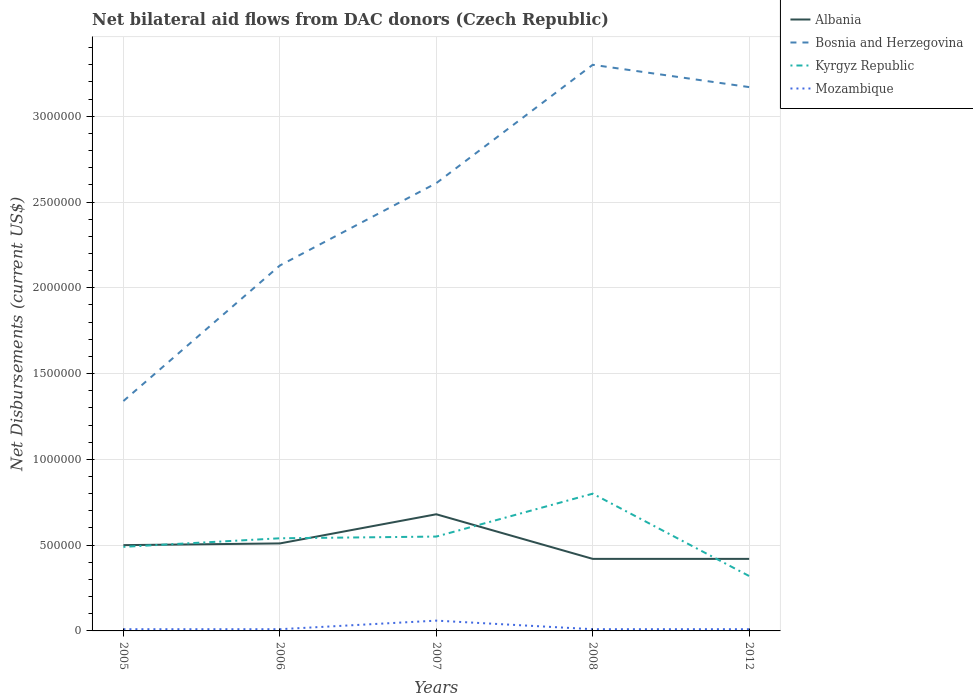Does the line corresponding to Bosnia and Herzegovina intersect with the line corresponding to Albania?
Your answer should be compact. No. In which year was the net bilateral aid flows in Kyrgyz Republic maximum?
Offer a terse response. 2012. What is the total net bilateral aid flows in Albania in the graph?
Your answer should be very brief. 9.00e+04. What is the difference between the highest and the lowest net bilateral aid flows in Bosnia and Herzegovina?
Ensure brevity in your answer.  3. How many lines are there?
Keep it short and to the point. 4. What is the difference between two consecutive major ticks on the Y-axis?
Your response must be concise. 5.00e+05. Are the values on the major ticks of Y-axis written in scientific E-notation?
Give a very brief answer. No. How many legend labels are there?
Provide a short and direct response. 4. What is the title of the graph?
Make the answer very short. Net bilateral aid flows from DAC donors (Czech Republic). What is the label or title of the Y-axis?
Ensure brevity in your answer.  Net Disbursements (current US$). What is the Net Disbursements (current US$) in Bosnia and Herzegovina in 2005?
Offer a terse response. 1.34e+06. What is the Net Disbursements (current US$) in Kyrgyz Republic in 2005?
Make the answer very short. 4.90e+05. What is the Net Disbursements (current US$) in Mozambique in 2005?
Your answer should be very brief. 10000. What is the Net Disbursements (current US$) of Albania in 2006?
Offer a very short reply. 5.10e+05. What is the Net Disbursements (current US$) of Bosnia and Herzegovina in 2006?
Your response must be concise. 2.13e+06. What is the Net Disbursements (current US$) of Kyrgyz Republic in 2006?
Provide a succinct answer. 5.40e+05. What is the Net Disbursements (current US$) in Mozambique in 2006?
Provide a short and direct response. 10000. What is the Net Disbursements (current US$) of Albania in 2007?
Your answer should be compact. 6.80e+05. What is the Net Disbursements (current US$) of Bosnia and Herzegovina in 2007?
Give a very brief answer. 2.61e+06. What is the Net Disbursements (current US$) of Kyrgyz Republic in 2007?
Your answer should be compact. 5.50e+05. What is the Net Disbursements (current US$) in Bosnia and Herzegovina in 2008?
Keep it short and to the point. 3.30e+06. What is the Net Disbursements (current US$) in Kyrgyz Republic in 2008?
Provide a short and direct response. 8.00e+05. What is the Net Disbursements (current US$) in Mozambique in 2008?
Provide a succinct answer. 10000. What is the Net Disbursements (current US$) of Bosnia and Herzegovina in 2012?
Your response must be concise. 3.17e+06. What is the Net Disbursements (current US$) in Kyrgyz Republic in 2012?
Offer a very short reply. 3.20e+05. What is the Net Disbursements (current US$) in Mozambique in 2012?
Provide a short and direct response. 10000. Across all years, what is the maximum Net Disbursements (current US$) in Albania?
Offer a terse response. 6.80e+05. Across all years, what is the maximum Net Disbursements (current US$) in Bosnia and Herzegovina?
Provide a succinct answer. 3.30e+06. Across all years, what is the maximum Net Disbursements (current US$) of Kyrgyz Republic?
Your answer should be compact. 8.00e+05. Across all years, what is the maximum Net Disbursements (current US$) in Mozambique?
Make the answer very short. 6.00e+04. Across all years, what is the minimum Net Disbursements (current US$) in Bosnia and Herzegovina?
Ensure brevity in your answer.  1.34e+06. Across all years, what is the minimum Net Disbursements (current US$) of Mozambique?
Keep it short and to the point. 10000. What is the total Net Disbursements (current US$) in Albania in the graph?
Provide a short and direct response. 2.53e+06. What is the total Net Disbursements (current US$) of Bosnia and Herzegovina in the graph?
Keep it short and to the point. 1.26e+07. What is the total Net Disbursements (current US$) of Kyrgyz Republic in the graph?
Your answer should be compact. 2.70e+06. What is the difference between the Net Disbursements (current US$) in Albania in 2005 and that in 2006?
Your response must be concise. -10000. What is the difference between the Net Disbursements (current US$) of Bosnia and Herzegovina in 2005 and that in 2006?
Provide a short and direct response. -7.90e+05. What is the difference between the Net Disbursements (current US$) of Mozambique in 2005 and that in 2006?
Keep it short and to the point. 0. What is the difference between the Net Disbursements (current US$) in Bosnia and Herzegovina in 2005 and that in 2007?
Your answer should be very brief. -1.27e+06. What is the difference between the Net Disbursements (current US$) in Kyrgyz Republic in 2005 and that in 2007?
Ensure brevity in your answer.  -6.00e+04. What is the difference between the Net Disbursements (current US$) of Bosnia and Herzegovina in 2005 and that in 2008?
Your answer should be compact. -1.96e+06. What is the difference between the Net Disbursements (current US$) in Kyrgyz Republic in 2005 and that in 2008?
Provide a short and direct response. -3.10e+05. What is the difference between the Net Disbursements (current US$) in Albania in 2005 and that in 2012?
Offer a terse response. 8.00e+04. What is the difference between the Net Disbursements (current US$) in Bosnia and Herzegovina in 2005 and that in 2012?
Provide a succinct answer. -1.83e+06. What is the difference between the Net Disbursements (current US$) of Kyrgyz Republic in 2005 and that in 2012?
Offer a very short reply. 1.70e+05. What is the difference between the Net Disbursements (current US$) in Albania in 2006 and that in 2007?
Your answer should be compact. -1.70e+05. What is the difference between the Net Disbursements (current US$) of Bosnia and Herzegovina in 2006 and that in 2007?
Your answer should be compact. -4.80e+05. What is the difference between the Net Disbursements (current US$) in Kyrgyz Republic in 2006 and that in 2007?
Your answer should be compact. -10000. What is the difference between the Net Disbursements (current US$) of Albania in 2006 and that in 2008?
Ensure brevity in your answer.  9.00e+04. What is the difference between the Net Disbursements (current US$) of Bosnia and Herzegovina in 2006 and that in 2008?
Ensure brevity in your answer.  -1.17e+06. What is the difference between the Net Disbursements (current US$) of Kyrgyz Republic in 2006 and that in 2008?
Make the answer very short. -2.60e+05. What is the difference between the Net Disbursements (current US$) in Bosnia and Herzegovina in 2006 and that in 2012?
Ensure brevity in your answer.  -1.04e+06. What is the difference between the Net Disbursements (current US$) in Mozambique in 2006 and that in 2012?
Keep it short and to the point. 0. What is the difference between the Net Disbursements (current US$) of Bosnia and Herzegovina in 2007 and that in 2008?
Provide a short and direct response. -6.90e+05. What is the difference between the Net Disbursements (current US$) in Mozambique in 2007 and that in 2008?
Your response must be concise. 5.00e+04. What is the difference between the Net Disbursements (current US$) in Bosnia and Herzegovina in 2007 and that in 2012?
Your response must be concise. -5.60e+05. What is the difference between the Net Disbursements (current US$) of Kyrgyz Republic in 2007 and that in 2012?
Give a very brief answer. 2.30e+05. What is the difference between the Net Disbursements (current US$) of Mozambique in 2007 and that in 2012?
Give a very brief answer. 5.00e+04. What is the difference between the Net Disbursements (current US$) of Bosnia and Herzegovina in 2008 and that in 2012?
Ensure brevity in your answer.  1.30e+05. What is the difference between the Net Disbursements (current US$) in Mozambique in 2008 and that in 2012?
Your answer should be very brief. 0. What is the difference between the Net Disbursements (current US$) in Albania in 2005 and the Net Disbursements (current US$) in Bosnia and Herzegovina in 2006?
Make the answer very short. -1.63e+06. What is the difference between the Net Disbursements (current US$) of Albania in 2005 and the Net Disbursements (current US$) of Mozambique in 2006?
Offer a terse response. 4.90e+05. What is the difference between the Net Disbursements (current US$) in Bosnia and Herzegovina in 2005 and the Net Disbursements (current US$) in Kyrgyz Republic in 2006?
Provide a succinct answer. 8.00e+05. What is the difference between the Net Disbursements (current US$) in Bosnia and Herzegovina in 2005 and the Net Disbursements (current US$) in Mozambique in 2006?
Give a very brief answer. 1.33e+06. What is the difference between the Net Disbursements (current US$) of Kyrgyz Republic in 2005 and the Net Disbursements (current US$) of Mozambique in 2006?
Your answer should be very brief. 4.80e+05. What is the difference between the Net Disbursements (current US$) of Albania in 2005 and the Net Disbursements (current US$) of Bosnia and Herzegovina in 2007?
Provide a succinct answer. -2.11e+06. What is the difference between the Net Disbursements (current US$) in Bosnia and Herzegovina in 2005 and the Net Disbursements (current US$) in Kyrgyz Republic in 2007?
Your response must be concise. 7.90e+05. What is the difference between the Net Disbursements (current US$) in Bosnia and Herzegovina in 2005 and the Net Disbursements (current US$) in Mozambique in 2007?
Offer a terse response. 1.28e+06. What is the difference between the Net Disbursements (current US$) in Kyrgyz Republic in 2005 and the Net Disbursements (current US$) in Mozambique in 2007?
Your answer should be very brief. 4.30e+05. What is the difference between the Net Disbursements (current US$) of Albania in 2005 and the Net Disbursements (current US$) of Bosnia and Herzegovina in 2008?
Offer a very short reply. -2.80e+06. What is the difference between the Net Disbursements (current US$) in Bosnia and Herzegovina in 2005 and the Net Disbursements (current US$) in Kyrgyz Republic in 2008?
Make the answer very short. 5.40e+05. What is the difference between the Net Disbursements (current US$) in Bosnia and Herzegovina in 2005 and the Net Disbursements (current US$) in Mozambique in 2008?
Make the answer very short. 1.33e+06. What is the difference between the Net Disbursements (current US$) of Kyrgyz Republic in 2005 and the Net Disbursements (current US$) of Mozambique in 2008?
Your answer should be compact. 4.80e+05. What is the difference between the Net Disbursements (current US$) of Albania in 2005 and the Net Disbursements (current US$) of Bosnia and Herzegovina in 2012?
Your answer should be compact. -2.67e+06. What is the difference between the Net Disbursements (current US$) in Albania in 2005 and the Net Disbursements (current US$) in Kyrgyz Republic in 2012?
Keep it short and to the point. 1.80e+05. What is the difference between the Net Disbursements (current US$) in Albania in 2005 and the Net Disbursements (current US$) in Mozambique in 2012?
Your answer should be very brief. 4.90e+05. What is the difference between the Net Disbursements (current US$) in Bosnia and Herzegovina in 2005 and the Net Disbursements (current US$) in Kyrgyz Republic in 2012?
Provide a short and direct response. 1.02e+06. What is the difference between the Net Disbursements (current US$) of Bosnia and Herzegovina in 2005 and the Net Disbursements (current US$) of Mozambique in 2012?
Provide a short and direct response. 1.33e+06. What is the difference between the Net Disbursements (current US$) of Albania in 2006 and the Net Disbursements (current US$) of Bosnia and Herzegovina in 2007?
Your answer should be very brief. -2.10e+06. What is the difference between the Net Disbursements (current US$) in Bosnia and Herzegovina in 2006 and the Net Disbursements (current US$) in Kyrgyz Republic in 2007?
Provide a short and direct response. 1.58e+06. What is the difference between the Net Disbursements (current US$) in Bosnia and Herzegovina in 2006 and the Net Disbursements (current US$) in Mozambique in 2007?
Make the answer very short. 2.07e+06. What is the difference between the Net Disbursements (current US$) in Albania in 2006 and the Net Disbursements (current US$) in Bosnia and Herzegovina in 2008?
Offer a very short reply. -2.79e+06. What is the difference between the Net Disbursements (current US$) in Albania in 2006 and the Net Disbursements (current US$) in Mozambique in 2008?
Offer a terse response. 5.00e+05. What is the difference between the Net Disbursements (current US$) of Bosnia and Herzegovina in 2006 and the Net Disbursements (current US$) of Kyrgyz Republic in 2008?
Make the answer very short. 1.33e+06. What is the difference between the Net Disbursements (current US$) in Bosnia and Herzegovina in 2006 and the Net Disbursements (current US$) in Mozambique in 2008?
Your response must be concise. 2.12e+06. What is the difference between the Net Disbursements (current US$) of Kyrgyz Republic in 2006 and the Net Disbursements (current US$) of Mozambique in 2008?
Make the answer very short. 5.30e+05. What is the difference between the Net Disbursements (current US$) of Albania in 2006 and the Net Disbursements (current US$) of Bosnia and Herzegovina in 2012?
Make the answer very short. -2.66e+06. What is the difference between the Net Disbursements (current US$) in Albania in 2006 and the Net Disbursements (current US$) in Kyrgyz Republic in 2012?
Keep it short and to the point. 1.90e+05. What is the difference between the Net Disbursements (current US$) in Bosnia and Herzegovina in 2006 and the Net Disbursements (current US$) in Kyrgyz Republic in 2012?
Offer a very short reply. 1.81e+06. What is the difference between the Net Disbursements (current US$) in Bosnia and Herzegovina in 2006 and the Net Disbursements (current US$) in Mozambique in 2012?
Provide a short and direct response. 2.12e+06. What is the difference between the Net Disbursements (current US$) of Kyrgyz Republic in 2006 and the Net Disbursements (current US$) of Mozambique in 2012?
Offer a very short reply. 5.30e+05. What is the difference between the Net Disbursements (current US$) of Albania in 2007 and the Net Disbursements (current US$) of Bosnia and Herzegovina in 2008?
Keep it short and to the point. -2.62e+06. What is the difference between the Net Disbursements (current US$) in Albania in 2007 and the Net Disbursements (current US$) in Kyrgyz Republic in 2008?
Your response must be concise. -1.20e+05. What is the difference between the Net Disbursements (current US$) of Albania in 2007 and the Net Disbursements (current US$) of Mozambique in 2008?
Your answer should be very brief. 6.70e+05. What is the difference between the Net Disbursements (current US$) in Bosnia and Herzegovina in 2007 and the Net Disbursements (current US$) in Kyrgyz Republic in 2008?
Provide a short and direct response. 1.81e+06. What is the difference between the Net Disbursements (current US$) in Bosnia and Herzegovina in 2007 and the Net Disbursements (current US$) in Mozambique in 2008?
Give a very brief answer. 2.60e+06. What is the difference between the Net Disbursements (current US$) of Kyrgyz Republic in 2007 and the Net Disbursements (current US$) of Mozambique in 2008?
Give a very brief answer. 5.40e+05. What is the difference between the Net Disbursements (current US$) of Albania in 2007 and the Net Disbursements (current US$) of Bosnia and Herzegovina in 2012?
Make the answer very short. -2.49e+06. What is the difference between the Net Disbursements (current US$) in Albania in 2007 and the Net Disbursements (current US$) in Kyrgyz Republic in 2012?
Keep it short and to the point. 3.60e+05. What is the difference between the Net Disbursements (current US$) in Albania in 2007 and the Net Disbursements (current US$) in Mozambique in 2012?
Offer a terse response. 6.70e+05. What is the difference between the Net Disbursements (current US$) of Bosnia and Herzegovina in 2007 and the Net Disbursements (current US$) of Kyrgyz Republic in 2012?
Provide a short and direct response. 2.29e+06. What is the difference between the Net Disbursements (current US$) of Bosnia and Herzegovina in 2007 and the Net Disbursements (current US$) of Mozambique in 2012?
Keep it short and to the point. 2.60e+06. What is the difference between the Net Disbursements (current US$) of Kyrgyz Republic in 2007 and the Net Disbursements (current US$) of Mozambique in 2012?
Provide a succinct answer. 5.40e+05. What is the difference between the Net Disbursements (current US$) of Albania in 2008 and the Net Disbursements (current US$) of Bosnia and Herzegovina in 2012?
Your answer should be compact. -2.75e+06. What is the difference between the Net Disbursements (current US$) of Albania in 2008 and the Net Disbursements (current US$) of Kyrgyz Republic in 2012?
Offer a terse response. 1.00e+05. What is the difference between the Net Disbursements (current US$) in Albania in 2008 and the Net Disbursements (current US$) in Mozambique in 2012?
Provide a succinct answer. 4.10e+05. What is the difference between the Net Disbursements (current US$) of Bosnia and Herzegovina in 2008 and the Net Disbursements (current US$) of Kyrgyz Republic in 2012?
Ensure brevity in your answer.  2.98e+06. What is the difference between the Net Disbursements (current US$) of Bosnia and Herzegovina in 2008 and the Net Disbursements (current US$) of Mozambique in 2012?
Your answer should be very brief. 3.29e+06. What is the difference between the Net Disbursements (current US$) in Kyrgyz Republic in 2008 and the Net Disbursements (current US$) in Mozambique in 2012?
Ensure brevity in your answer.  7.90e+05. What is the average Net Disbursements (current US$) of Albania per year?
Give a very brief answer. 5.06e+05. What is the average Net Disbursements (current US$) in Bosnia and Herzegovina per year?
Offer a terse response. 2.51e+06. What is the average Net Disbursements (current US$) of Kyrgyz Republic per year?
Your answer should be very brief. 5.40e+05. In the year 2005, what is the difference between the Net Disbursements (current US$) in Albania and Net Disbursements (current US$) in Bosnia and Herzegovina?
Your answer should be very brief. -8.40e+05. In the year 2005, what is the difference between the Net Disbursements (current US$) in Albania and Net Disbursements (current US$) in Mozambique?
Give a very brief answer. 4.90e+05. In the year 2005, what is the difference between the Net Disbursements (current US$) of Bosnia and Herzegovina and Net Disbursements (current US$) of Kyrgyz Republic?
Keep it short and to the point. 8.50e+05. In the year 2005, what is the difference between the Net Disbursements (current US$) in Bosnia and Herzegovina and Net Disbursements (current US$) in Mozambique?
Give a very brief answer. 1.33e+06. In the year 2006, what is the difference between the Net Disbursements (current US$) of Albania and Net Disbursements (current US$) of Bosnia and Herzegovina?
Ensure brevity in your answer.  -1.62e+06. In the year 2006, what is the difference between the Net Disbursements (current US$) of Albania and Net Disbursements (current US$) of Kyrgyz Republic?
Offer a terse response. -3.00e+04. In the year 2006, what is the difference between the Net Disbursements (current US$) of Bosnia and Herzegovina and Net Disbursements (current US$) of Kyrgyz Republic?
Your answer should be very brief. 1.59e+06. In the year 2006, what is the difference between the Net Disbursements (current US$) of Bosnia and Herzegovina and Net Disbursements (current US$) of Mozambique?
Offer a very short reply. 2.12e+06. In the year 2006, what is the difference between the Net Disbursements (current US$) of Kyrgyz Republic and Net Disbursements (current US$) of Mozambique?
Provide a short and direct response. 5.30e+05. In the year 2007, what is the difference between the Net Disbursements (current US$) in Albania and Net Disbursements (current US$) in Bosnia and Herzegovina?
Provide a succinct answer. -1.93e+06. In the year 2007, what is the difference between the Net Disbursements (current US$) in Albania and Net Disbursements (current US$) in Mozambique?
Offer a very short reply. 6.20e+05. In the year 2007, what is the difference between the Net Disbursements (current US$) in Bosnia and Herzegovina and Net Disbursements (current US$) in Kyrgyz Republic?
Keep it short and to the point. 2.06e+06. In the year 2007, what is the difference between the Net Disbursements (current US$) in Bosnia and Herzegovina and Net Disbursements (current US$) in Mozambique?
Offer a very short reply. 2.55e+06. In the year 2007, what is the difference between the Net Disbursements (current US$) of Kyrgyz Republic and Net Disbursements (current US$) of Mozambique?
Provide a succinct answer. 4.90e+05. In the year 2008, what is the difference between the Net Disbursements (current US$) of Albania and Net Disbursements (current US$) of Bosnia and Herzegovina?
Give a very brief answer. -2.88e+06. In the year 2008, what is the difference between the Net Disbursements (current US$) in Albania and Net Disbursements (current US$) in Kyrgyz Republic?
Your response must be concise. -3.80e+05. In the year 2008, what is the difference between the Net Disbursements (current US$) of Albania and Net Disbursements (current US$) of Mozambique?
Your response must be concise. 4.10e+05. In the year 2008, what is the difference between the Net Disbursements (current US$) in Bosnia and Herzegovina and Net Disbursements (current US$) in Kyrgyz Republic?
Ensure brevity in your answer.  2.50e+06. In the year 2008, what is the difference between the Net Disbursements (current US$) of Bosnia and Herzegovina and Net Disbursements (current US$) of Mozambique?
Your response must be concise. 3.29e+06. In the year 2008, what is the difference between the Net Disbursements (current US$) in Kyrgyz Republic and Net Disbursements (current US$) in Mozambique?
Provide a short and direct response. 7.90e+05. In the year 2012, what is the difference between the Net Disbursements (current US$) of Albania and Net Disbursements (current US$) of Bosnia and Herzegovina?
Make the answer very short. -2.75e+06. In the year 2012, what is the difference between the Net Disbursements (current US$) of Bosnia and Herzegovina and Net Disbursements (current US$) of Kyrgyz Republic?
Your answer should be compact. 2.85e+06. In the year 2012, what is the difference between the Net Disbursements (current US$) in Bosnia and Herzegovina and Net Disbursements (current US$) in Mozambique?
Give a very brief answer. 3.16e+06. What is the ratio of the Net Disbursements (current US$) of Albania in 2005 to that in 2006?
Make the answer very short. 0.98. What is the ratio of the Net Disbursements (current US$) of Bosnia and Herzegovina in 2005 to that in 2006?
Offer a very short reply. 0.63. What is the ratio of the Net Disbursements (current US$) in Kyrgyz Republic in 2005 to that in 2006?
Your answer should be compact. 0.91. What is the ratio of the Net Disbursements (current US$) of Albania in 2005 to that in 2007?
Give a very brief answer. 0.74. What is the ratio of the Net Disbursements (current US$) in Bosnia and Herzegovina in 2005 to that in 2007?
Make the answer very short. 0.51. What is the ratio of the Net Disbursements (current US$) in Kyrgyz Republic in 2005 to that in 2007?
Make the answer very short. 0.89. What is the ratio of the Net Disbursements (current US$) of Mozambique in 2005 to that in 2007?
Ensure brevity in your answer.  0.17. What is the ratio of the Net Disbursements (current US$) of Albania in 2005 to that in 2008?
Your response must be concise. 1.19. What is the ratio of the Net Disbursements (current US$) in Bosnia and Herzegovina in 2005 to that in 2008?
Your response must be concise. 0.41. What is the ratio of the Net Disbursements (current US$) in Kyrgyz Republic in 2005 to that in 2008?
Offer a terse response. 0.61. What is the ratio of the Net Disbursements (current US$) of Mozambique in 2005 to that in 2008?
Offer a terse response. 1. What is the ratio of the Net Disbursements (current US$) of Albania in 2005 to that in 2012?
Your answer should be very brief. 1.19. What is the ratio of the Net Disbursements (current US$) of Bosnia and Herzegovina in 2005 to that in 2012?
Your response must be concise. 0.42. What is the ratio of the Net Disbursements (current US$) of Kyrgyz Republic in 2005 to that in 2012?
Give a very brief answer. 1.53. What is the ratio of the Net Disbursements (current US$) in Albania in 2006 to that in 2007?
Your answer should be compact. 0.75. What is the ratio of the Net Disbursements (current US$) in Bosnia and Herzegovina in 2006 to that in 2007?
Make the answer very short. 0.82. What is the ratio of the Net Disbursements (current US$) of Kyrgyz Republic in 2006 to that in 2007?
Offer a terse response. 0.98. What is the ratio of the Net Disbursements (current US$) of Mozambique in 2006 to that in 2007?
Provide a succinct answer. 0.17. What is the ratio of the Net Disbursements (current US$) of Albania in 2006 to that in 2008?
Provide a short and direct response. 1.21. What is the ratio of the Net Disbursements (current US$) in Bosnia and Herzegovina in 2006 to that in 2008?
Provide a succinct answer. 0.65. What is the ratio of the Net Disbursements (current US$) of Kyrgyz Republic in 2006 to that in 2008?
Give a very brief answer. 0.68. What is the ratio of the Net Disbursements (current US$) of Albania in 2006 to that in 2012?
Your answer should be very brief. 1.21. What is the ratio of the Net Disbursements (current US$) in Bosnia and Herzegovina in 2006 to that in 2012?
Your response must be concise. 0.67. What is the ratio of the Net Disbursements (current US$) in Kyrgyz Republic in 2006 to that in 2012?
Offer a very short reply. 1.69. What is the ratio of the Net Disbursements (current US$) in Mozambique in 2006 to that in 2012?
Your response must be concise. 1. What is the ratio of the Net Disbursements (current US$) in Albania in 2007 to that in 2008?
Make the answer very short. 1.62. What is the ratio of the Net Disbursements (current US$) in Bosnia and Herzegovina in 2007 to that in 2008?
Provide a succinct answer. 0.79. What is the ratio of the Net Disbursements (current US$) of Kyrgyz Republic in 2007 to that in 2008?
Provide a short and direct response. 0.69. What is the ratio of the Net Disbursements (current US$) in Albania in 2007 to that in 2012?
Provide a succinct answer. 1.62. What is the ratio of the Net Disbursements (current US$) in Bosnia and Herzegovina in 2007 to that in 2012?
Keep it short and to the point. 0.82. What is the ratio of the Net Disbursements (current US$) of Kyrgyz Republic in 2007 to that in 2012?
Provide a succinct answer. 1.72. What is the ratio of the Net Disbursements (current US$) in Mozambique in 2007 to that in 2012?
Your response must be concise. 6. What is the ratio of the Net Disbursements (current US$) in Bosnia and Herzegovina in 2008 to that in 2012?
Offer a very short reply. 1.04. What is the ratio of the Net Disbursements (current US$) of Mozambique in 2008 to that in 2012?
Offer a terse response. 1. What is the difference between the highest and the second highest Net Disbursements (current US$) of Albania?
Your answer should be compact. 1.70e+05. What is the difference between the highest and the second highest Net Disbursements (current US$) in Bosnia and Herzegovina?
Ensure brevity in your answer.  1.30e+05. What is the difference between the highest and the lowest Net Disbursements (current US$) of Albania?
Keep it short and to the point. 2.60e+05. What is the difference between the highest and the lowest Net Disbursements (current US$) of Bosnia and Herzegovina?
Your answer should be very brief. 1.96e+06. What is the difference between the highest and the lowest Net Disbursements (current US$) of Kyrgyz Republic?
Ensure brevity in your answer.  4.80e+05. 